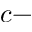<formula> <loc_0><loc_0><loc_500><loc_500>c -</formula> 